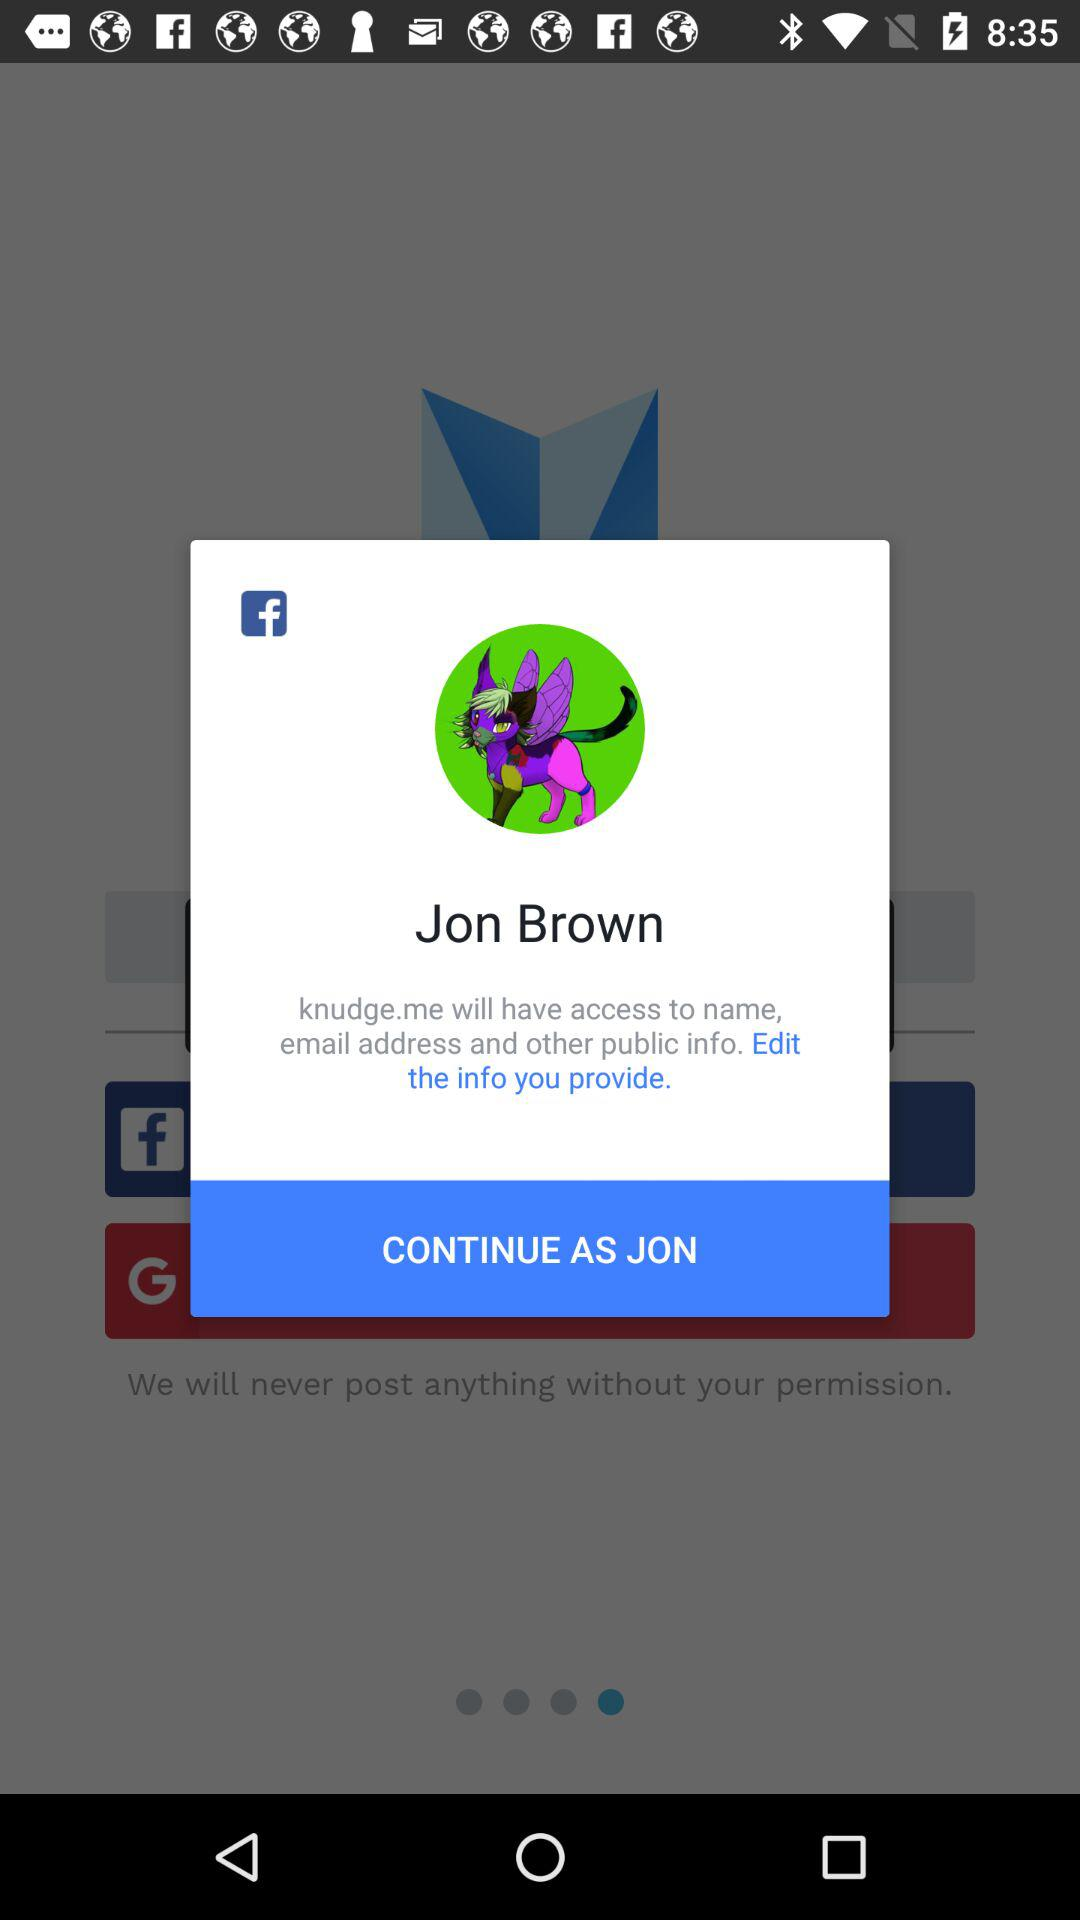Which email address will "knudge.me" have access to?
When the provided information is insufficient, respond with <no answer>. <no answer> 